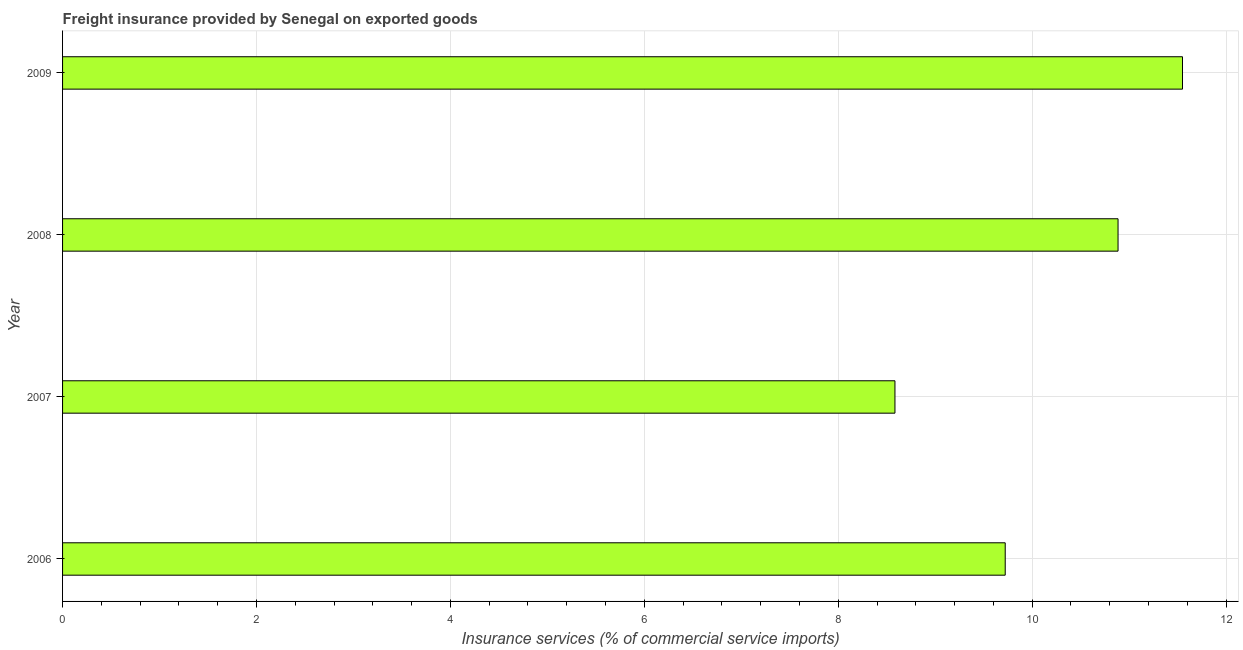Does the graph contain any zero values?
Keep it short and to the point. No. Does the graph contain grids?
Offer a very short reply. Yes. What is the title of the graph?
Make the answer very short. Freight insurance provided by Senegal on exported goods . What is the label or title of the X-axis?
Offer a very short reply. Insurance services (% of commercial service imports). What is the label or title of the Y-axis?
Offer a very short reply. Year. What is the freight insurance in 2006?
Offer a very short reply. 9.72. Across all years, what is the maximum freight insurance?
Make the answer very short. 11.55. Across all years, what is the minimum freight insurance?
Keep it short and to the point. 8.59. In which year was the freight insurance maximum?
Give a very brief answer. 2009. What is the sum of the freight insurance?
Give a very brief answer. 40.74. What is the difference between the freight insurance in 2006 and 2008?
Provide a succinct answer. -1.16. What is the average freight insurance per year?
Offer a very short reply. 10.19. What is the median freight insurance?
Make the answer very short. 10.3. In how many years, is the freight insurance greater than 4.8 %?
Provide a succinct answer. 4. What is the ratio of the freight insurance in 2006 to that in 2009?
Provide a short and direct response. 0.84. Is the difference between the freight insurance in 2006 and 2007 greater than the difference between any two years?
Keep it short and to the point. No. What is the difference between the highest and the second highest freight insurance?
Offer a terse response. 0.67. What is the difference between the highest and the lowest freight insurance?
Keep it short and to the point. 2.97. In how many years, is the freight insurance greater than the average freight insurance taken over all years?
Your response must be concise. 2. How many bars are there?
Your answer should be compact. 4. How many years are there in the graph?
Offer a very short reply. 4. What is the difference between two consecutive major ticks on the X-axis?
Provide a succinct answer. 2. Are the values on the major ticks of X-axis written in scientific E-notation?
Ensure brevity in your answer.  No. What is the Insurance services (% of commercial service imports) in 2006?
Offer a very short reply. 9.72. What is the Insurance services (% of commercial service imports) in 2007?
Your response must be concise. 8.59. What is the Insurance services (% of commercial service imports) in 2008?
Offer a very short reply. 10.89. What is the Insurance services (% of commercial service imports) of 2009?
Offer a very short reply. 11.55. What is the difference between the Insurance services (% of commercial service imports) in 2006 and 2007?
Ensure brevity in your answer.  1.14. What is the difference between the Insurance services (% of commercial service imports) in 2006 and 2008?
Your response must be concise. -1.16. What is the difference between the Insurance services (% of commercial service imports) in 2006 and 2009?
Make the answer very short. -1.83. What is the difference between the Insurance services (% of commercial service imports) in 2007 and 2008?
Ensure brevity in your answer.  -2.3. What is the difference between the Insurance services (% of commercial service imports) in 2007 and 2009?
Give a very brief answer. -2.97. What is the difference between the Insurance services (% of commercial service imports) in 2008 and 2009?
Ensure brevity in your answer.  -0.66. What is the ratio of the Insurance services (% of commercial service imports) in 2006 to that in 2007?
Your answer should be very brief. 1.13. What is the ratio of the Insurance services (% of commercial service imports) in 2006 to that in 2008?
Provide a succinct answer. 0.89. What is the ratio of the Insurance services (% of commercial service imports) in 2006 to that in 2009?
Provide a succinct answer. 0.84. What is the ratio of the Insurance services (% of commercial service imports) in 2007 to that in 2008?
Your answer should be very brief. 0.79. What is the ratio of the Insurance services (% of commercial service imports) in 2007 to that in 2009?
Your answer should be compact. 0.74. What is the ratio of the Insurance services (% of commercial service imports) in 2008 to that in 2009?
Ensure brevity in your answer.  0.94. 